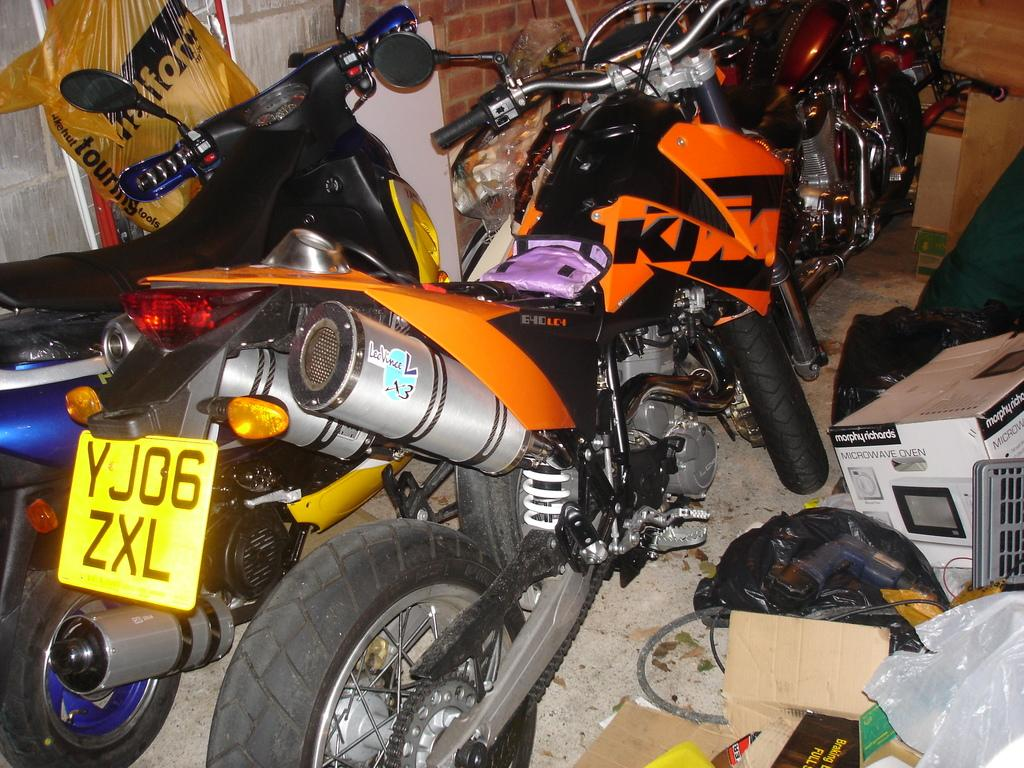What type of vehicles are in the image? There are motorbikes in the image. What objects are beside the motorbikes? There are boxes beside the motorbikes. What can be seen in the background of the image? There is a brick wall in the background of the image. What type of lace can be seen on the motorbikes in the image? There is no lace present on the motorbikes in the image. What type of bait is being used to catch fish in the image? There is no fishing or bait present in the image; it features motorbikes and boxes. 